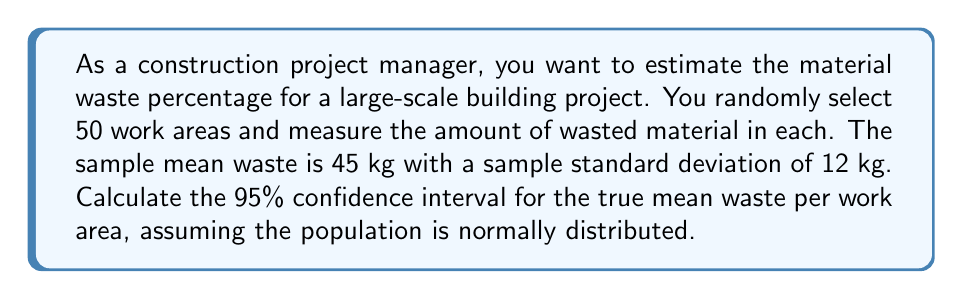Can you solve this math problem? To calculate the confidence interval, we'll use the formula:

$$\bar{x} \pm t_{\alpha/2, n-1} \cdot \frac{s}{\sqrt{n}}$$

Where:
$\bar{x}$ = sample mean
$t_{\alpha/2, n-1}$ = t-value for 95% confidence level with n-1 degrees of freedom
$s$ = sample standard deviation
$n$ = sample size

Step 1: Identify the known values
$\bar{x} = 45$ kg
$s = 12$ kg
$n = 50$
Confidence level = 95%

Step 2: Find the t-value
For a 95% confidence level and 49 degrees of freedom (n-1 = 50-1 = 49), the t-value is approximately 2.01 (from t-distribution table)

Step 3: Calculate the margin of error
Margin of error = $t_{\alpha/2, n-1} \cdot \frac{s}{\sqrt{n}}$
$= 2.01 \cdot \frac{12}{\sqrt{50}}$
$= 2.01 \cdot 1.697$
$= 3.41$ kg

Step 4: Calculate the confidence interval
Lower bound = $45 - 3.41 = 41.59$ kg
Upper bound = $45 + 3.41 = 48.41$ kg

Therefore, we can be 95% confident that the true mean waste per work area is between 41.59 kg and 48.41 kg.
Answer: (41.59 kg, 48.41 kg) 